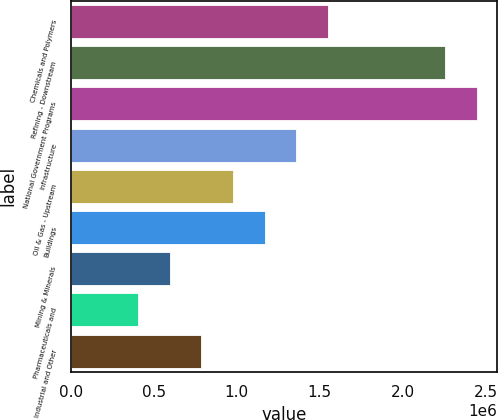Convert chart to OTSL. <chart><loc_0><loc_0><loc_500><loc_500><bar_chart><fcel>Chemicals and Polymers<fcel>Refining - Downstream<fcel>National Government Programs<fcel>Infrastructure<fcel>Oil & Gas - Upstream<fcel>Buildings<fcel>Mining & Minerals<fcel>Pharmaceuticals and<fcel>Industrial and Other<nl><fcel>1.54982e+06<fcel>2.25609e+06<fcel>2.44695e+06<fcel>1.35896e+06<fcel>977253<fcel>1.16811e+06<fcel>595542<fcel>404687<fcel>786398<nl></chart> 